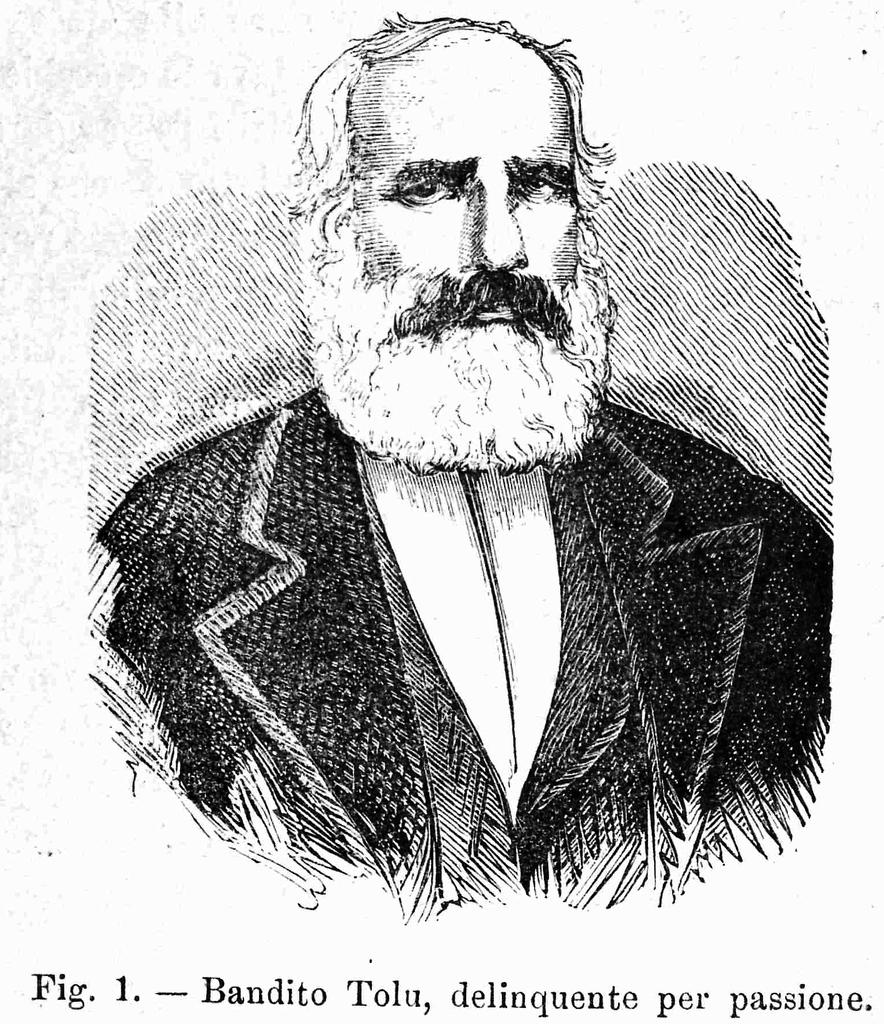What is the main subject of the image? There is a poster in the image. What is depicted on the poster? The poster features a person wearing a suit. Are there any words or text on the poster? Yes, there are words written at the bottom of the image. How many eggs are visible in the image? There are no eggs present in the image. What type of industry is depicted in the image? There is no industry depicted in the image; it features a person wearing a suit on a poster. 